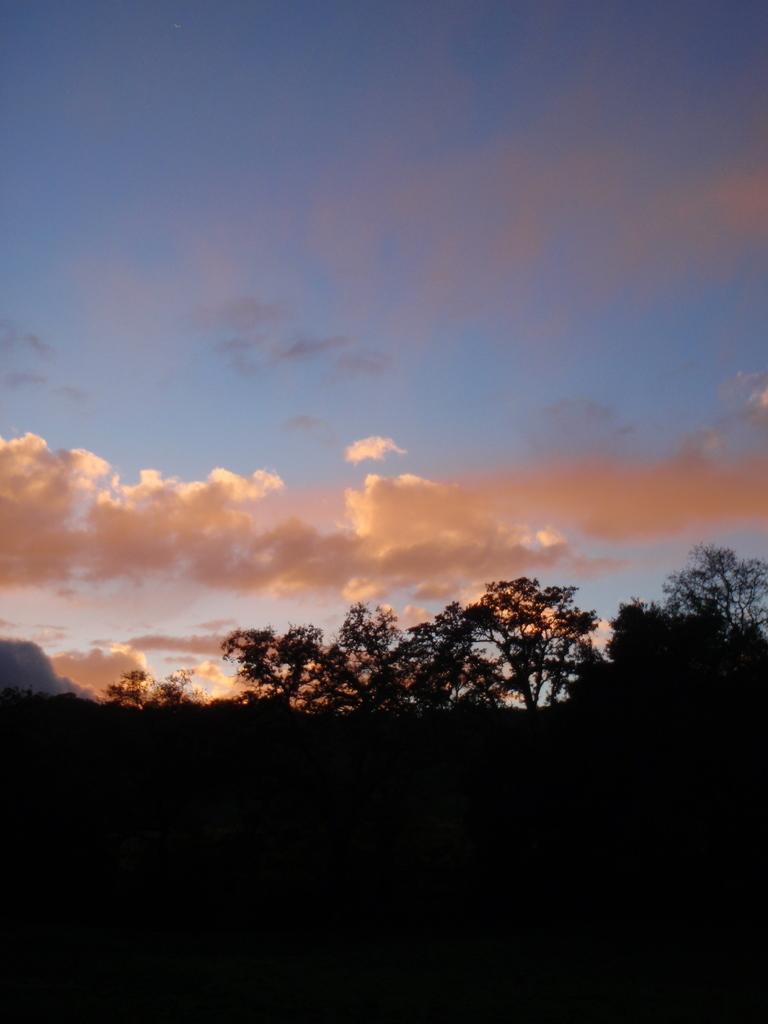Can you describe this image briefly? In front of the image there are trees. In the background of the image there are clouds in the sky. 